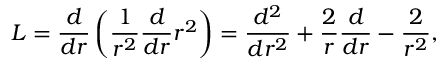Convert formula to latex. <formula><loc_0><loc_0><loc_500><loc_500>L = \frac { d } { d r } \left ( \frac { 1 } { r ^ { 2 } } \frac { d } { d r } r ^ { 2 } \right ) = \frac { d ^ { 2 } } { d r ^ { 2 } } + \frac { 2 } { r } \frac { d } { d r } - \frac { 2 } { r ^ { 2 } } ,</formula> 